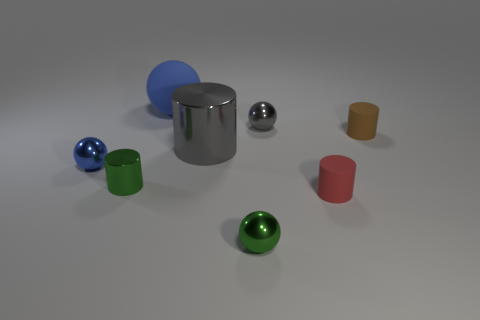Is the material of the small green cylinder the same as the small blue thing?
Ensure brevity in your answer.  Yes. Are there fewer tiny green matte cubes than small red cylinders?
Your response must be concise. Yes. Is the tiny blue metal object the same shape as the small red rubber thing?
Ensure brevity in your answer.  No. The large metallic thing has what color?
Make the answer very short. Gray. What number of other objects are there of the same material as the tiny green sphere?
Your response must be concise. 4. How many green objects are either large shiny objects or small shiny objects?
Make the answer very short. 2. Do the gray object that is in front of the tiny gray thing and the tiny green object that is on the right side of the green metallic cylinder have the same shape?
Keep it short and to the point. No. There is a big rubber thing; is it the same color as the tiny rubber cylinder on the right side of the red matte thing?
Provide a succinct answer. No. There is a tiny cylinder left of the big gray cylinder; is its color the same as the large rubber ball?
Your response must be concise. No. How many objects are either matte spheres or small cylinders to the right of the rubber ball?
Provide a succinct answer. 3. 